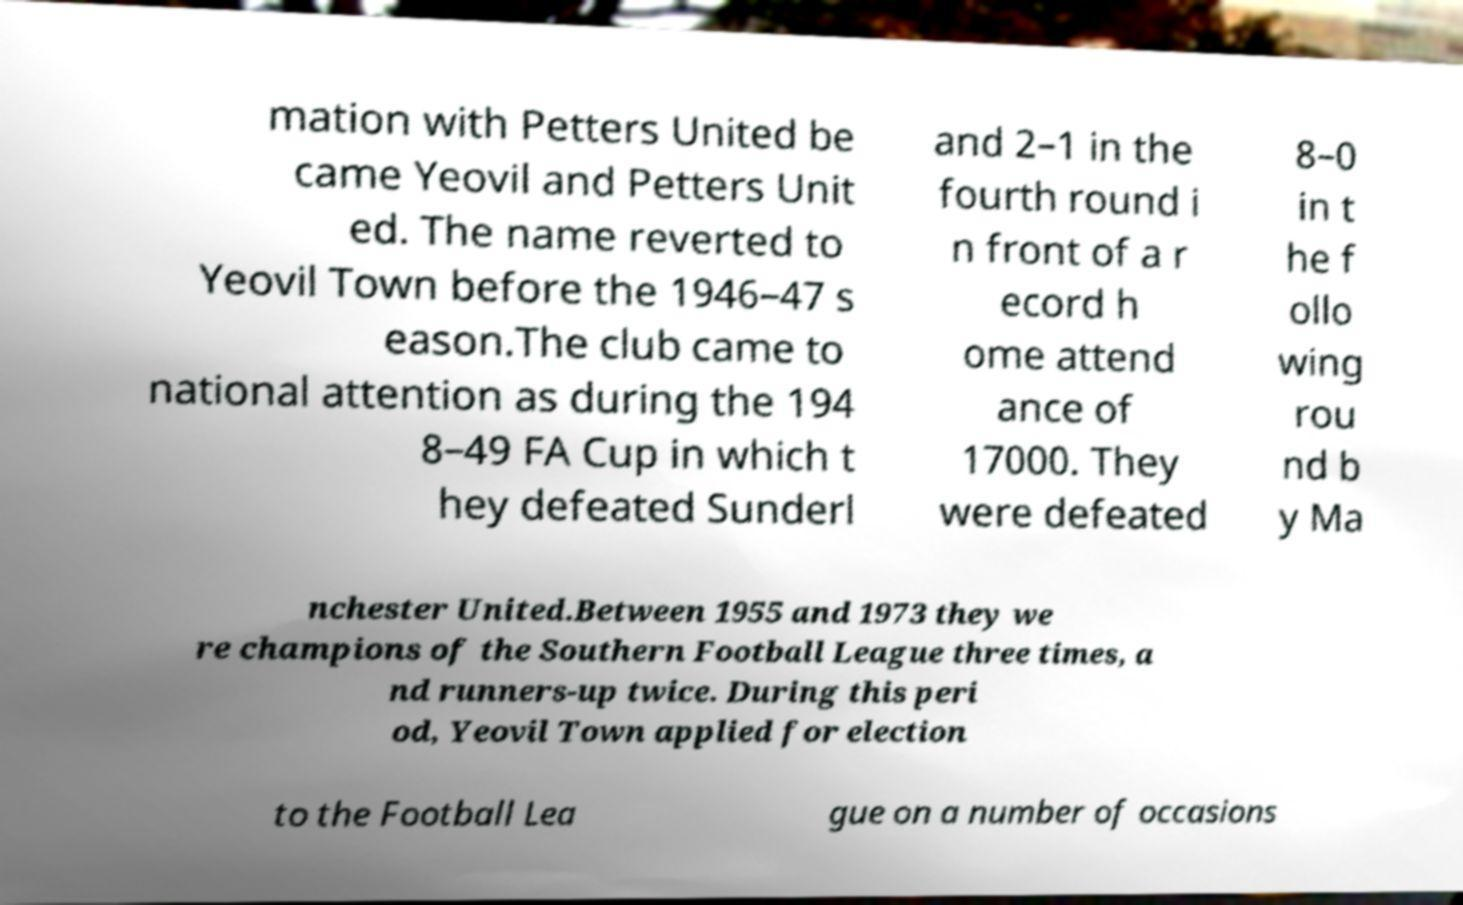Please identify and transcribe the text found in this image. mation with Petters United be came Yeovil and Petters Unit ed. The name reverted to Yeovil Town before the 1946–47 s eason.The club came to national attention as during the 194 8–49 FA Cup in which t hey defeated Sunderl and 2–1 in the fourth round i n front of a r ecord h ome attend ance of 17000. They were defeated 8–0 in t he f ollo wing rou nd b y Ma nchester United.Between 1955 and 1973 they we re champions of the Southern Football League three times, a nd runners-up twice. During this peri od, Yeovil Town applied for election to the Football Lea gue on a number of occasions 